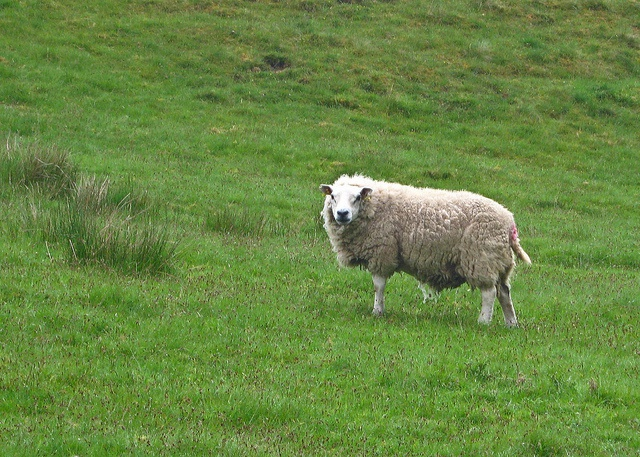Describe the objects in this image and their specific colors. I can see a sheep in green, gray, white, and darkgray tones in this image. 